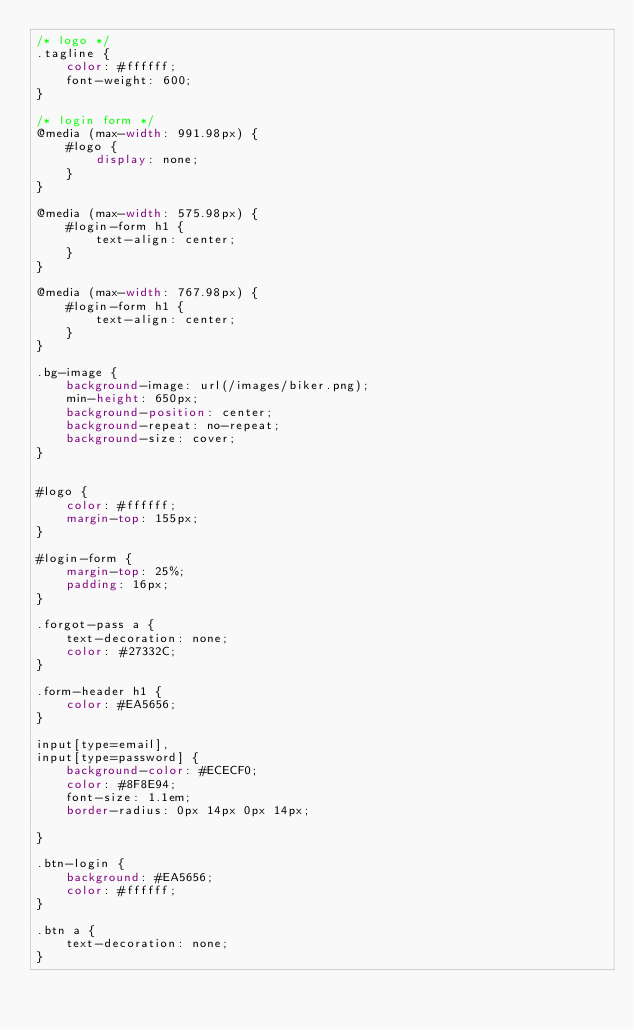<code> <loc_0><loc_0><loc_500><loc_500><_CSS_>/* logo */
.tagline {
    color: #ffffff;
    font-weight: 600;
}

/* login form */
@media (max-width: 991.98px) {
    #logo {
        display: none;
    }
}

@media (max-width: 575.98px) {
    #login-form h1 {
        text-align: center;
    }
}

@media (max-width: 767.98px) {
    #login-form h1 {
        text-align: center;
    }
}

.bg-image {
    background-image: url(/images/biker.png);
    min-height: 650px;
    background-position: center;
    background-repeat: no-repeat;
    background-size: cover;
}


#logo {
    color: #ffffff;
    margin-top: 155px;
}

#login-form {  
    margin-top: 25%;
    padding: 16px;   
}

.forgot-pass a {
    text-decoration: none;
    color: #27332C;
}

.form-header h1 {
    color: #EA5656;
}

input[type=email],
input[type=password] { 
    background-color: #ECECF0;
    color: #8F8E94;
    font-size: 1.1em;
    border-radius: 0px 14px 0px 14px;

}

.btn-login {
    background: #EA5656;
    color: #ffffff;
}

.btn a {
    text-decoration: none;
}

</code> 